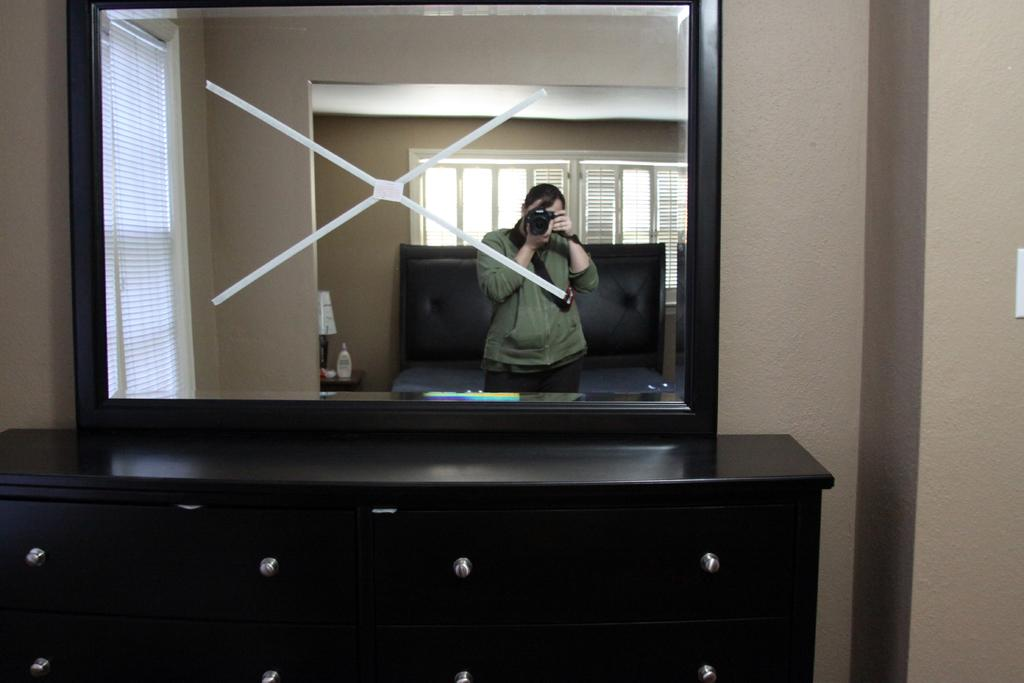What object is placed on the black table in the image? There is a mirror on a black table in the image. Who is present in the image? There is a woman with a camera in the image. What can be seen behind the woman and the table? There is a plain wall in the image. What type of loaf is being used as a prop in the image? There is no loaf present in the image. What shape is the mirror in the image? The shape of the mirror cannot be determined from the image alone, as it is not visible in the provided facts. 